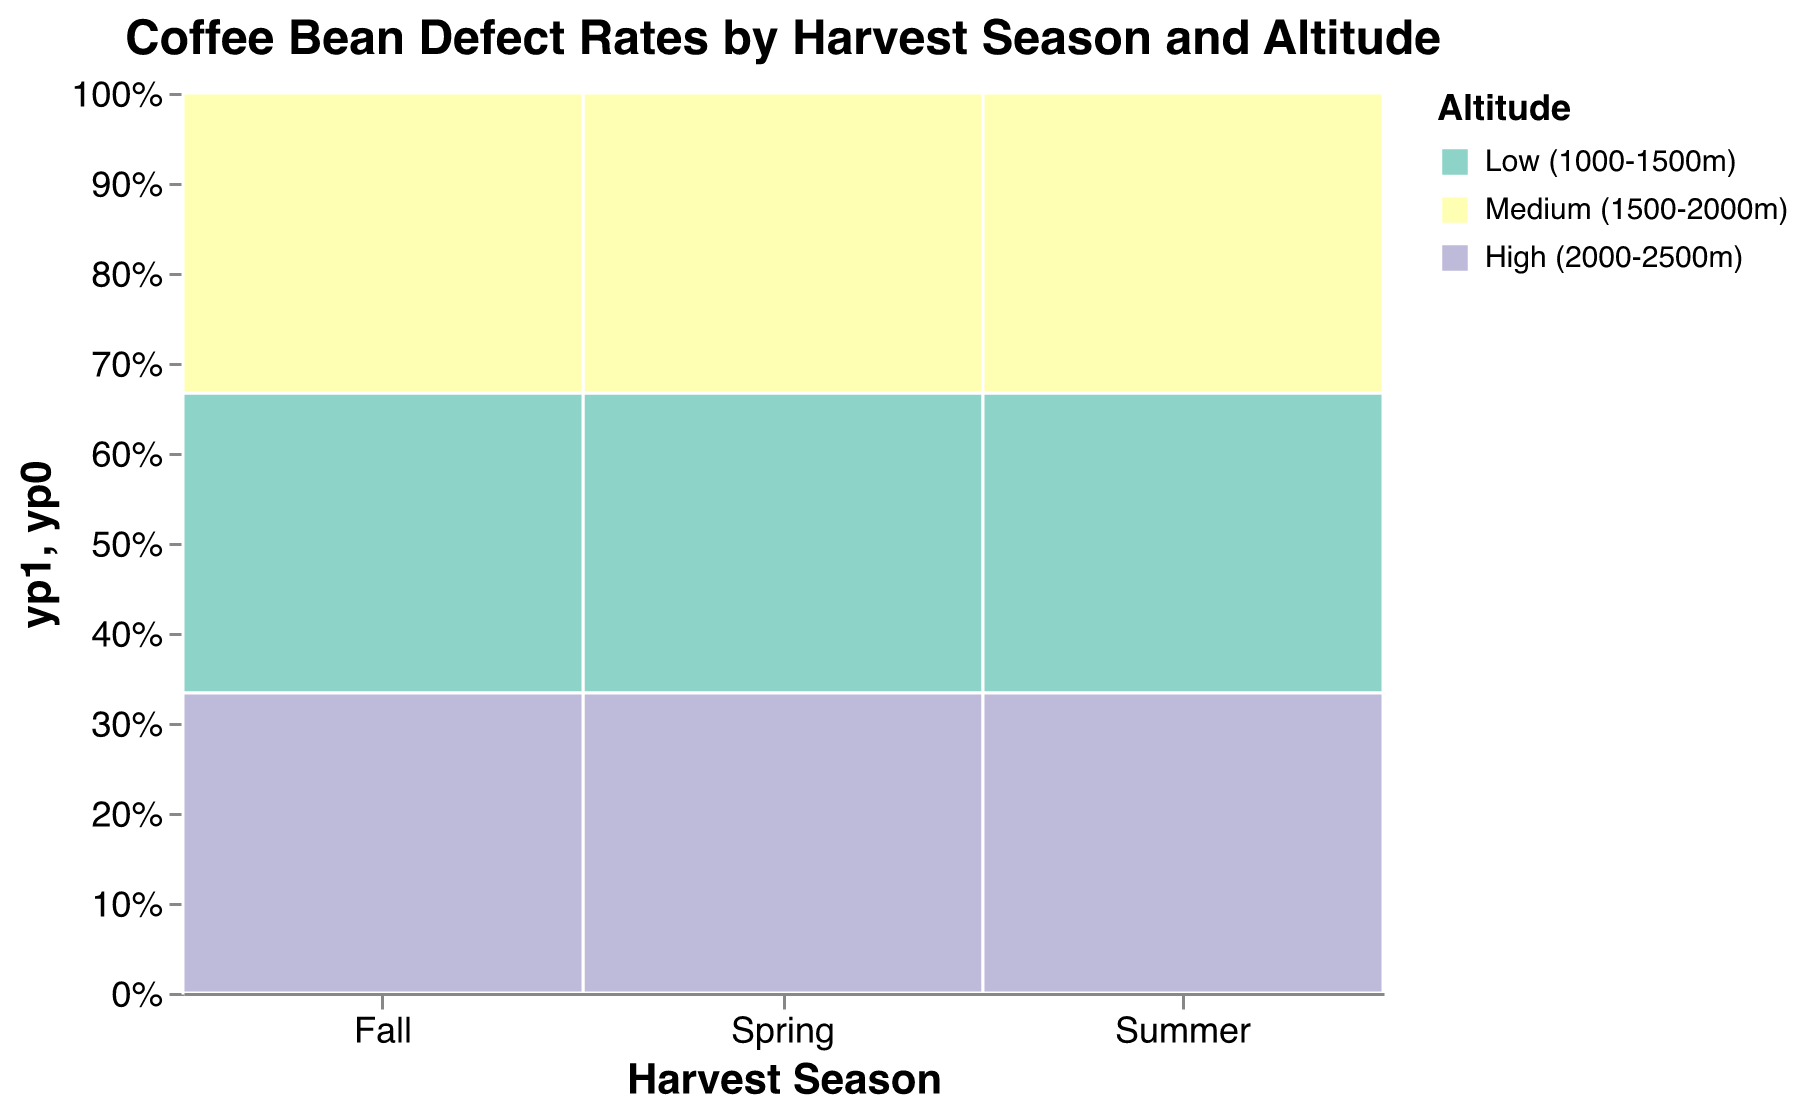Which harvest season has the highest coffee bean defect rates overall? By visually identifying the segments in each bar, Summer has comparatively larger segments representing the defect rates across different altitudes.
Answer: Summer Which altitude category has the lowest defect rate during the Fall season? By observing the Fall column and comparing the segments, the high altitude (2000-2500m) has the smallest segment, indicating the lowest defect rate.
Answer: High (2000-2500m) How does the defect rate in low altitude during Summer compare to Spring? By comparing the size of the 'Low (1000-1500m)' segments in Summer and Spring, the Summer segment is visibly larger, indicating a higher defect rate.
Answer: Higher in Summer What is the total bean count in the high altitude category across all seasons? Sum the bean counts for High (2000-2500m) across Spring (1800), Summer (1600), and Fall (1900). The total is (1800 + 1600 + 1900) = 5300.
Answer: 5300 What can be inferred about the distribution of defect rates by altitude within each season? Generally, segments get smaller as altitude increases within each harvest season column, indicating lower defect rates at higher altitudes. In all seasons, the 'High' segment is the smallest, followed by 'Medium', and 'Low' is the largest.
Answer: Higher altitudes have lower defect rates Which season has the most balanced distribution of defect rates across different altitudes? Observing each season's column, Spring has segments of varying sizes but comparatively more balanced across 'Low', 'Medium', and 'High' altitudes than Summer and Fall.
Answer: Spring How does the medium altitude defect rate in Fall compare to Spring? By comparing the 'Medium (1500-2000m)' segments in Fall and Spring, the Fall segment is slightly smaller, indicating a lower defect rate.
Answer: Lower in Fall Which specific combination of season and altitude has the highest defect rate? The largest segment is in the Summer season with Low (1000-1500m) altitude.
Answer: Summer, Low (1000-1500m) What trends can you observe in the defect rates as altitude increases within each season? As altitude increases from Low to High within each season, defect rates decrease, evidenced by the progressive reduction in segment sizes from low to high altitude within each season bar.
Answer: Decrease with higher altitude 